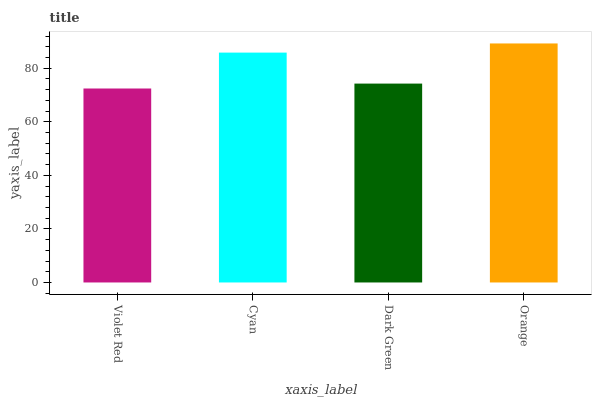Is Cyan the minimum?
Answer yes or no. No. Is Cyan the maximum?
Answer yes or no. No. Is Cyan greater than Violet Red?
Answer yes or no. Yes. Is Violet Red less than Cyan?
Answer yes or no. Yes. Is Violet Red greater than Cyan?
Answer yes or no. No. Is Cyan less than Violet Red?
Answer yes or no. No. Is Cyan the high median?
Answer yes or no. Yes. Is Dark Green the low median?
Answer yes or no. Yes. Is Orange the high median?
Answer yes or no. No. Is Orange the low median?
Answer yes or no. No. 